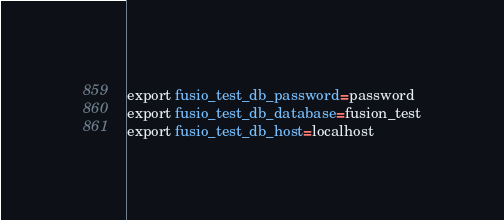<code> <loc_0><loc_0><loc_500><loc_500><_Bash_>export fusio_test_db_password=password
export fusio_test_db_database=fusion_test
export fusio_test_db_host=localhost
</code> 